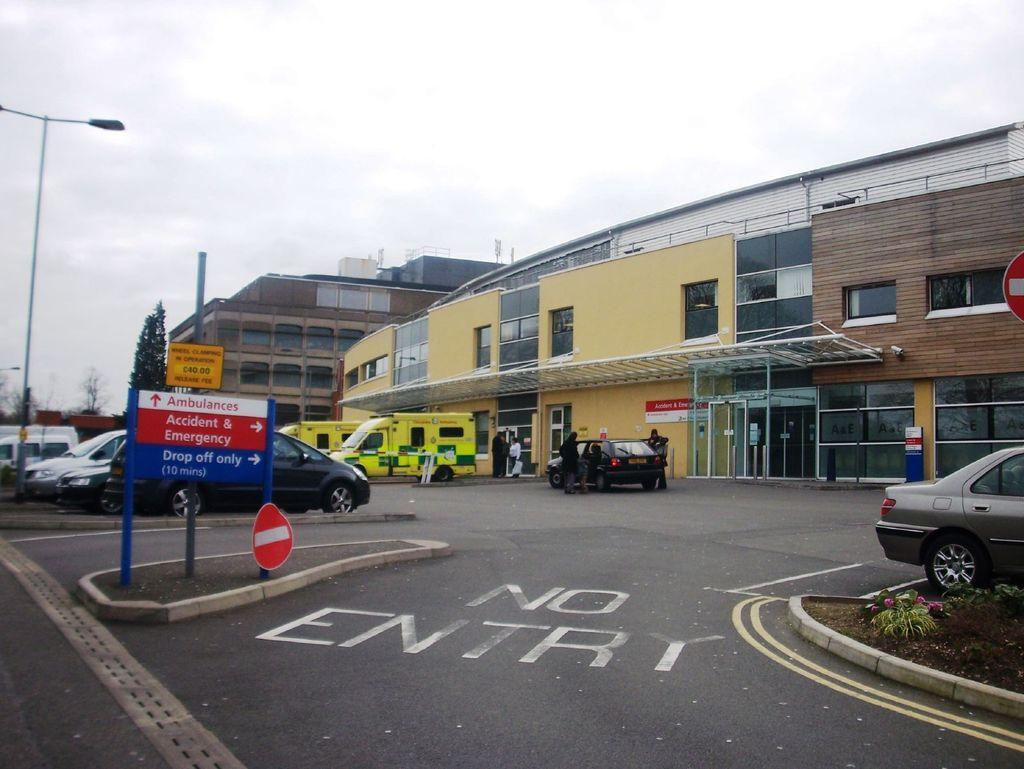In one or two sentences, can you explain what this image depicts? In this image we can see buildings, vehicles, cars, persons, door, windows, street light, sign boards, flowers, plants, trees, sky and clouds. 